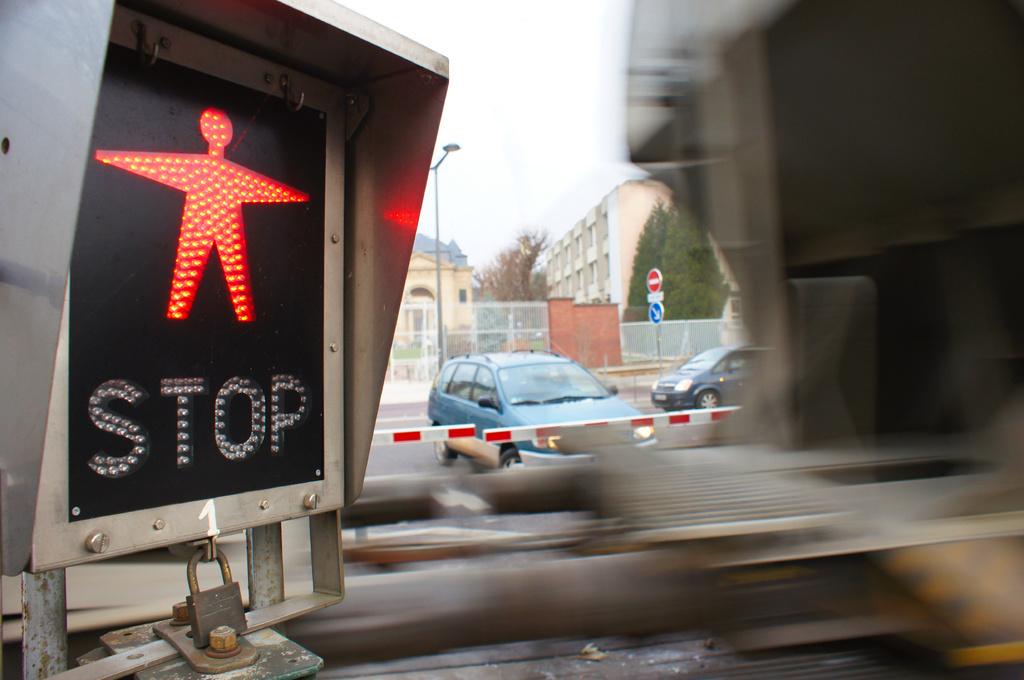What are the letters on the sign?
Offer a terse response. Stop. 